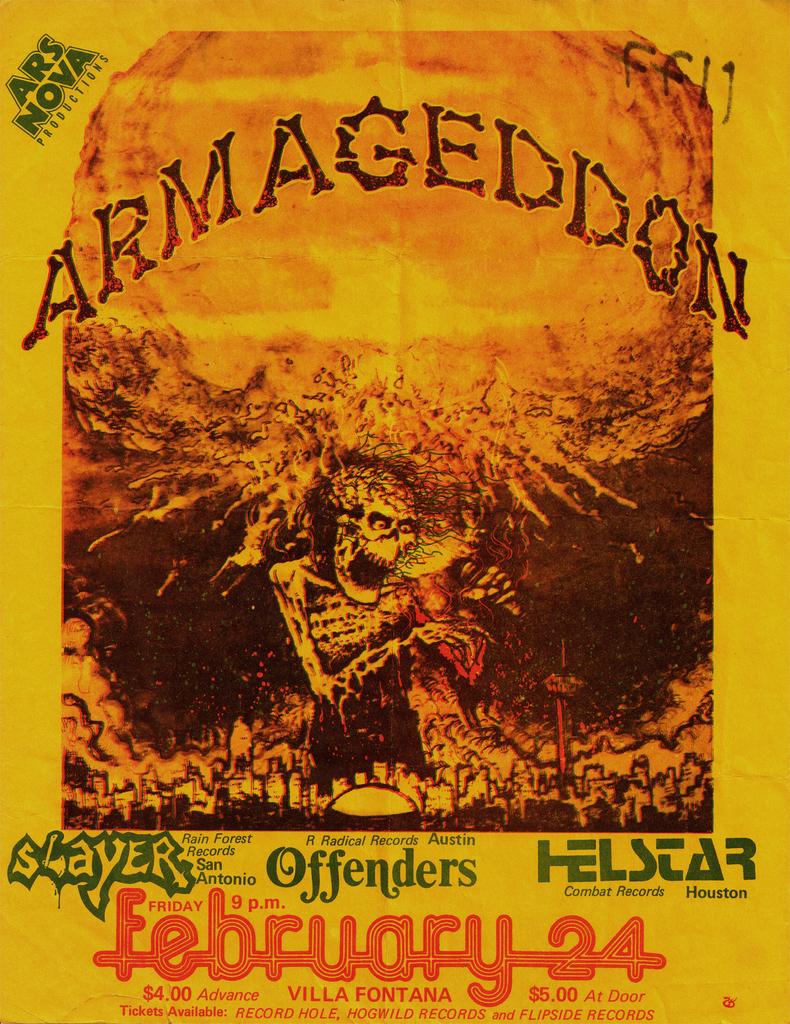Is armageddon onl playing at the villa fontana?
Offer a very short reply. Yes. 